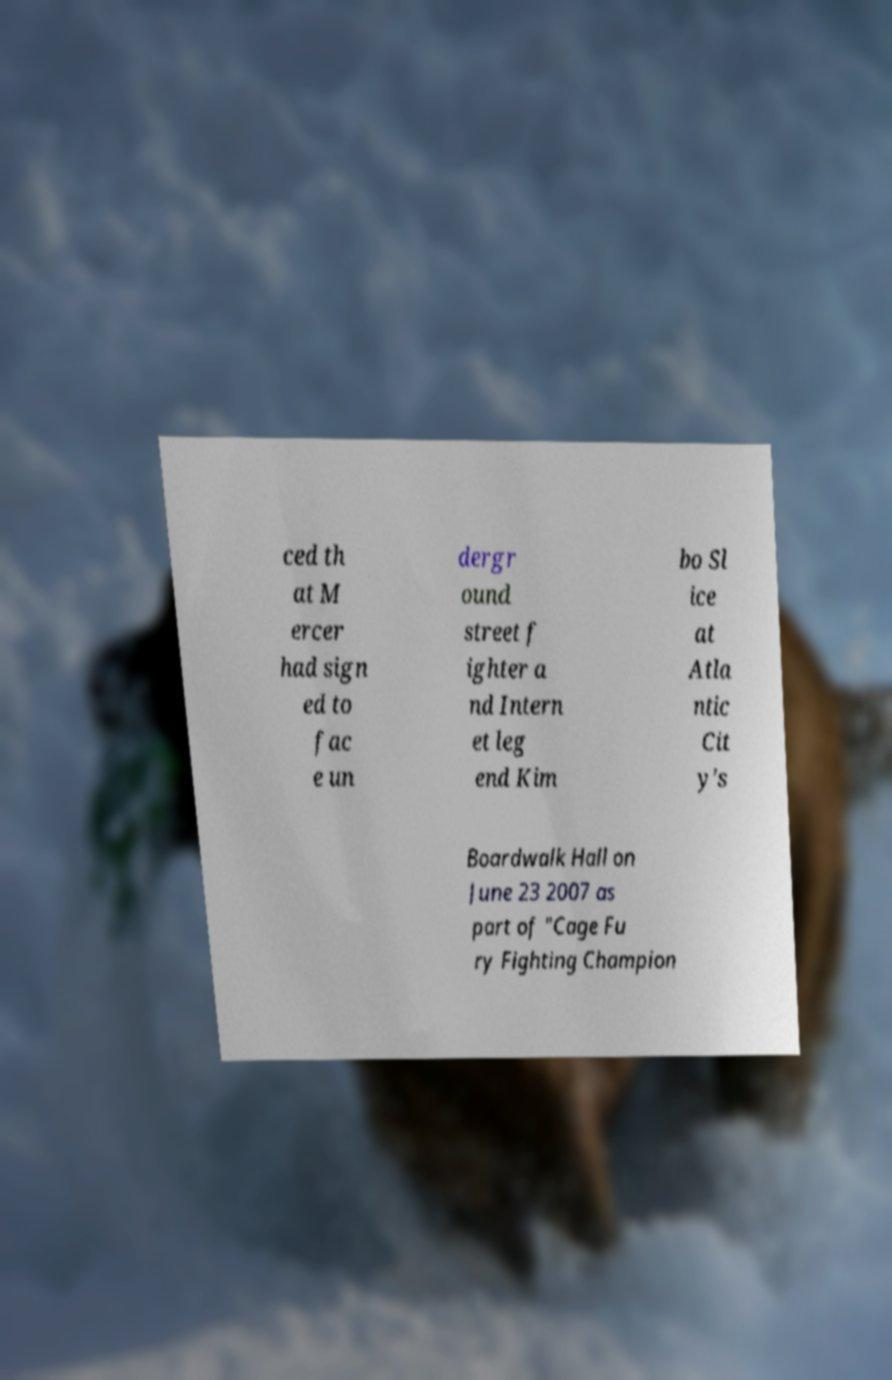Please identify and transcribe the text found in this image. ced th at M ercer had sign ed to fac e un dergr ound street f ighter a nd Intern et leg end Kim bo Sl ice at Atla ntic Cit y's Boardwalk Hall on June 23 2007 as part of "Cage Fu ry Fighting Champion 